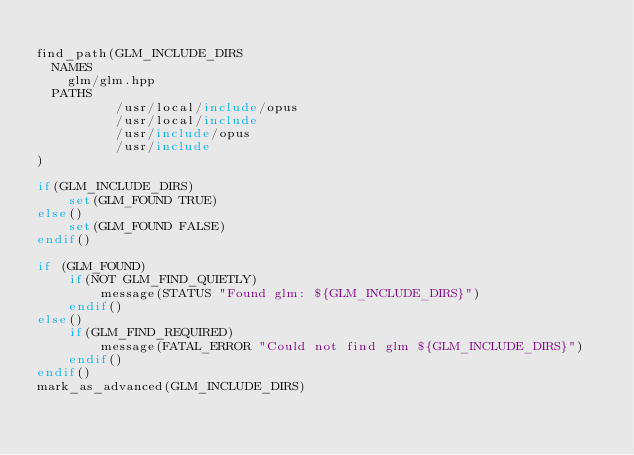<code> <loc_0><loc_0><loc_500><loc_500><_CMake_>
find_path(GLM_INCLUDE_DIRS 
	NAMES 
		glm/glm.hpp
	PATHS
          /usr/local/include/opus
          /usr/local/include
          /usr/include/opus
          /usr/include
)

if(GLM_INCLUDE_DIRS)
    set(GLM_FOUND TRUE)
else()
    set(GLM_FOUND FALSE)
endif()

if (GLM_FOUND)
    if(NOT GLM_FIND_QUIETLY)
        message(STATUS "Found glm: ${GLM_INCLUDE_DIRS}")
    endif()
else()
    if(GLM_FIND_REQUIRED)
        message(FATAL_ERROR "Could not find glm ${GLM_INCLUDE_DIRS}")
    endif()
endif()
mark_as_advanced(GLM_INCLUDE_DIRS)
</code> 